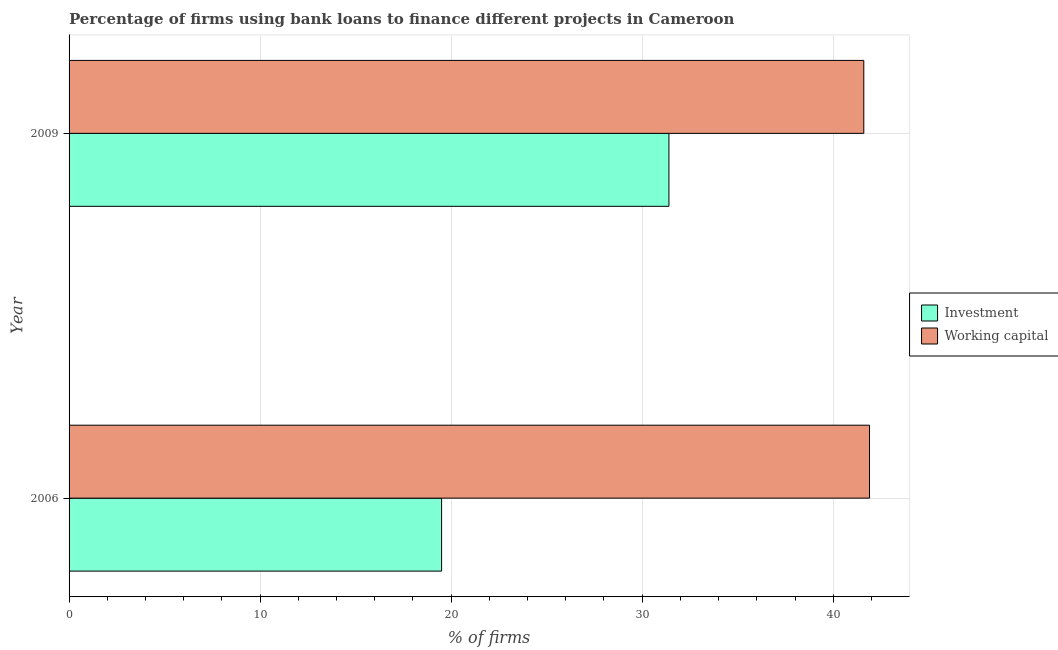Are the number of bars per tick equal to the number of legend labels?
Your response must be concise. Yes. How many bars are there on the 2nd tick from the top?
Your response must be concise. 2. What is the label of the 2nd group of bars from the top?
Provide a succinct answer. 2006. What is the percentage of firms using banks to finance working capital in 2006?
Offer a very short reply. 41.9. Across all years, what is the maximum percentage of firms using banks to finance investment?
Keep it short and to the point. 31.4. Across all years, what is the minimum percentage of firms using banks to finance investment?
Keep it short and to the point. 19.5. In which year was the percentage of firms using banks to finance working capital minimum?
Provide a succinct answer. 2009. What is the total percentage of firms using banks to finance working capital in the graph?
Give a very brief answer. 83.5. What is the difference between the percentage of firms using banks to finance working capital in 2006 and that in 2009?
Provide a succinct answer. 0.3. What is the difference between the percentage of firms using banks to finance investment in 2009 and the percentage of firms using banks to finance working capital in 2006?
Your response must be concise. -10.5. What is the average percentage of firms using banks to finance investment per year?
Your response must be concise. 25.45. In the year 2006, what is the difference between the percentage of firms using banks to finance working capital and percentage of firms using banks to finance investment?
Offer a terse response. 22.4. What is the ratio of the percentage of firms using banks to finance investment in 2006 to that in 2009?
Make the answer very short. 0.62. Is the percentage of firms using banks to finance investment in 2006 less than that in 2009?
Offer a very short reply. Yes. Is the difference between the percentage of firms using banks to finance working capital in 2006 and 2009 greater than the difference between the percentage of firms using banks to finance investment in 2006 and 2009?
Keep it short and to the point. Yes. What does the 1st bar from the top in 2009 represents?
Offer a terse response. Working capital. What does the 1st bar from the bottom in 2009 represents?
Offer a terse response. Investment. How many bars are there?
Provide a succinct answer. 4. How many years are there in the graph?
Your answer should be very brief. 2. Are the values on the major ticks of X-axis written in scientific E-notation?
Your answer should be compact. No. Does the graph contain any zero values?
Provide a succinct answer. No. How many legend labels are there?
Offer a terse response. 2. What is the title of the graph?
Offer a terse response. Percentage of firms using bank loans to finance different projects in Cameroon. What is the label or title of the X-axis?
Ensure brevity in your answer.  % of firms. What is the % of firms in Investment in 2006?
Your answer should be compact. 19.5. What is the % of firms in Working capital in 2006?
Your answer should be compact. 41.9. What is the % of firms in Investment in 2009?
Your answer should be very brief. 31.4. What is the % of firms in Working capital in 2009?
Ensure brevity in your answer.  41.6. Across all years, what is the maximum % of firms of Investment?
Give a very brief answer. 31.4. Across all years, what is the maximum % of firms of Working capital?
Your answer should be compact. 41.9. Across all years, what is the minimum % of firms in Working capital?
Give a very brief answer. 41.6. What is the total % of firms of Investment in the graph?
Ensure brevity in your answer.  50.9. What is the total % of firms in Working capital in the graph?
Make the answer very short. 83.5. What is the difference between the % of firms in Investment in 2006 and the % of firms in Working capital in 2009?
Offer a very short reply. -22.1. What is the average % of firms of Investment per year?
Give a very brief answer. 25.45. What is the average % of firms of Working capital per year?
Make the answer very short. 41.75. In the year 2006, what is the difference between the % of firms of Investment and % of firms of Working capital?
Provide a succinct answer. -22.4. In the year 2009, what is the difference between the % of firms in Investment and % of firms in Working capital?
Your answer should be very brief. -10.2. What is the ratio of the % of firms in Investment in 2006 to that in 2009?
Your answer should be very brief. 0.62. What is the difference between the highest and the second highest % of firms of Investment?
Give a very brief answer. 11.9. What is the difference between the highest and the lowest % of firms of Working capital?
Keep it short and to the point. 0.3. 